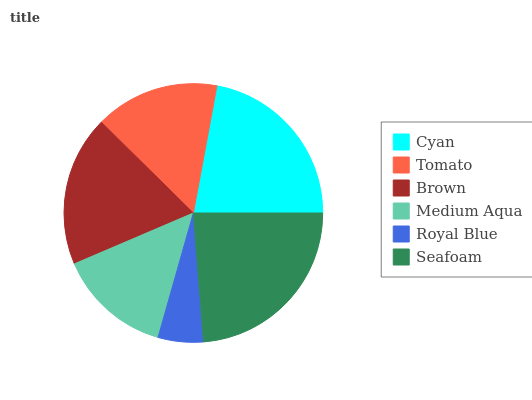Is Royal Blue the minimum?
Answer yes or no. Yes. Is Seafoam the maximum?
Answer yes or no. Yes. Is Tomato the minimum?
Answer yes or no. No. Is Tomato the maximum?
Answer yes or no. No. Is Cyan greater than Tomato?
Answer yes or no. Yes. Is Tomato less than Cyan?
Answer yes or no. Yes. Is Tomato greater than Cyan?
Answer yes or no. No. Is Cyan less than Tomato?
Answer yes or no. No. Is Brown the high median?
Answer yes or no. Yes. Is Tomato the low median?
Answer yes or no. Yes. Is Cyan the high median?
Answer yes or no. No. Is Medium Aqua the low median?
Answer yes or no. No. 